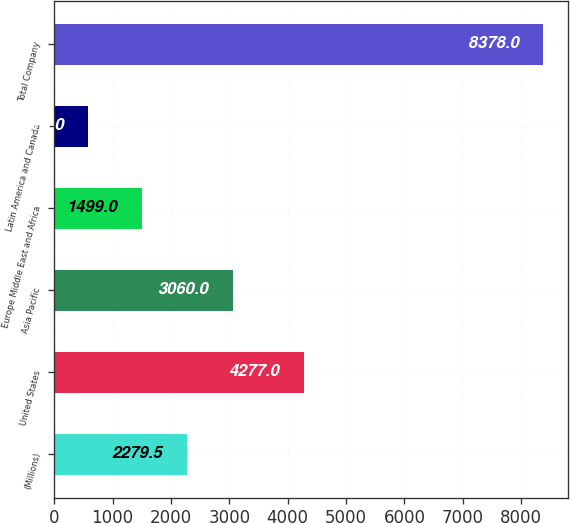<chart> <loc_0><loc_0><loc_500><loc_500><bar_chart><fcel>(Millions)<fcel>United States<fcel>Asia Pacific<fcel>Europe Middle East and Africa<fcel>Latin America and Canada<fcel>Total Company<nl><fcel>2279.5<fcel>4277<fcel>3060<fcel>1499<fcel>573<fcel>8378<nl></chart> 